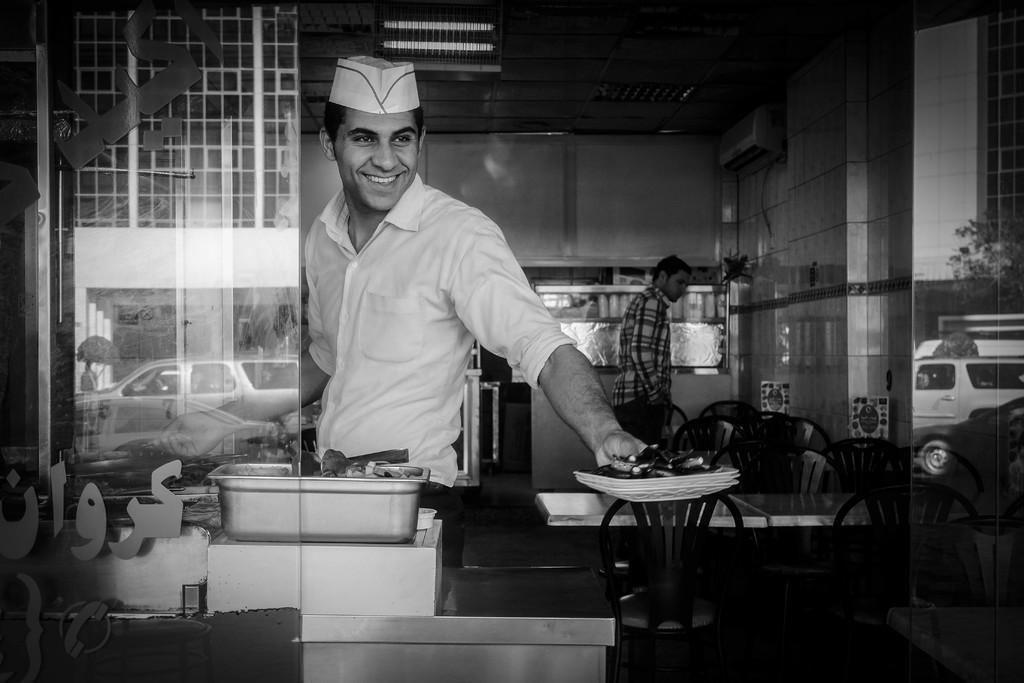Can you describe this image briefly? In this picture there are two persons standing. We can see chairs and tables. This person holding plate. There is a bowl. There is a glass. From this class we can see vehicle. this wear a cap. On the top we can see lights. 